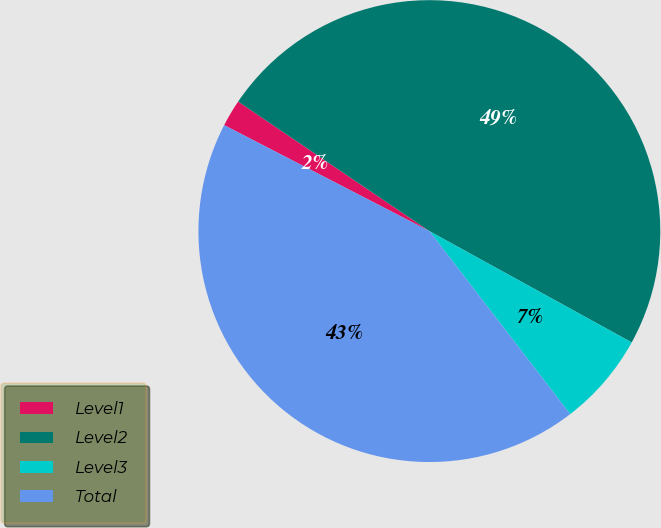Convert chart to OTSL. <chart><loc_0><loc_0><loc_500><loc_500><pie_chart><fcel>Level1<fcel>Level2<fcel>Level3<fcel>Total<nl><fcel>1.89%<fcel>48.53%<fcel>6.56%<fcel>43.02%<nl></chart> 